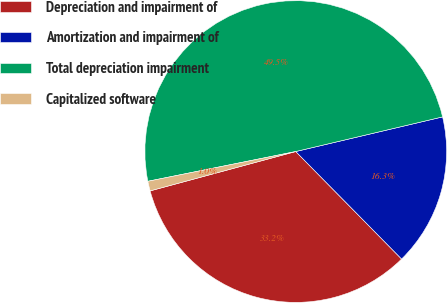Convert chart to OTSL. <chart><loc_0><loc_0><loc_500><loc_500><pie_chart><fcel>Depreciation and impairment of<fcel>Amortization and impairment of<fcel>Total depreciation impairment<fcel>Capitalized software<nl><fcel>33.18%<fcel>16.31%<fcel>49.48%<fcel>1.04%<nl></chart> 